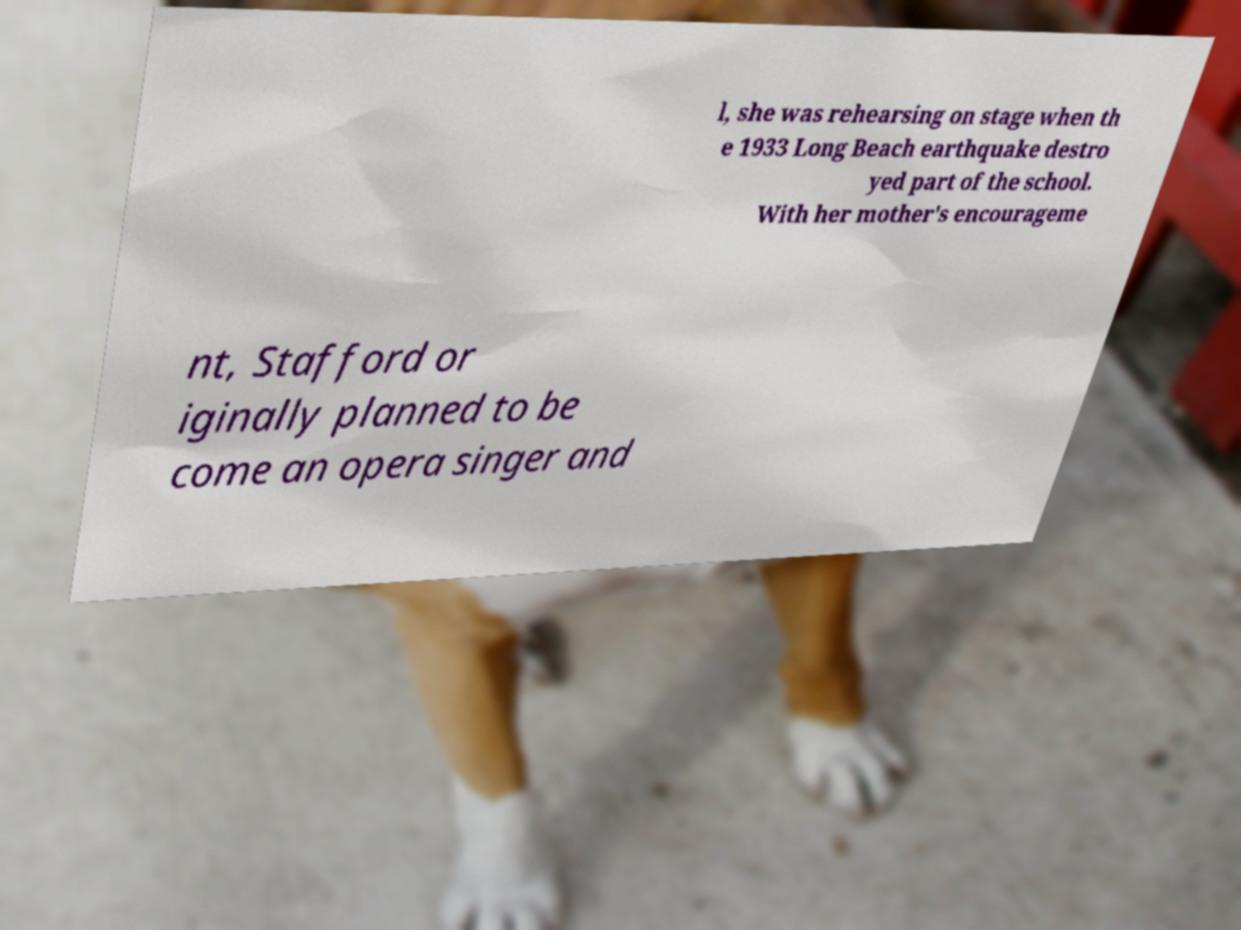Can you accurately transcribe the text from the provided image for me? l, she was rehearsing on stage when th e 1933 Long Beach earthquake destro yed part of the school. With her mother's encourageme nt, Stafford or iginally planned to be come an opera singer and 